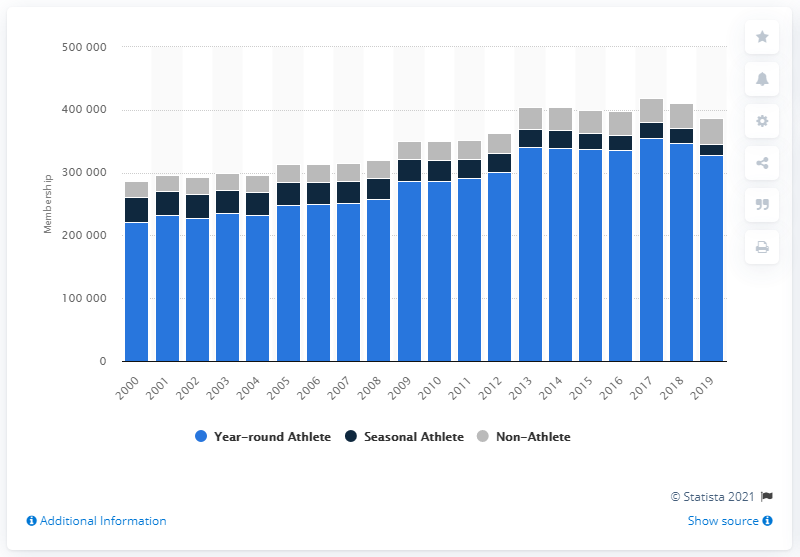Indicate a few pertinent items in this graphic. As of 2019, it is estimated that there were approximately 327,337 people who were year-round members of a swimming club in the United States. The number of USA Swimming memberships increased in the year 2000. 